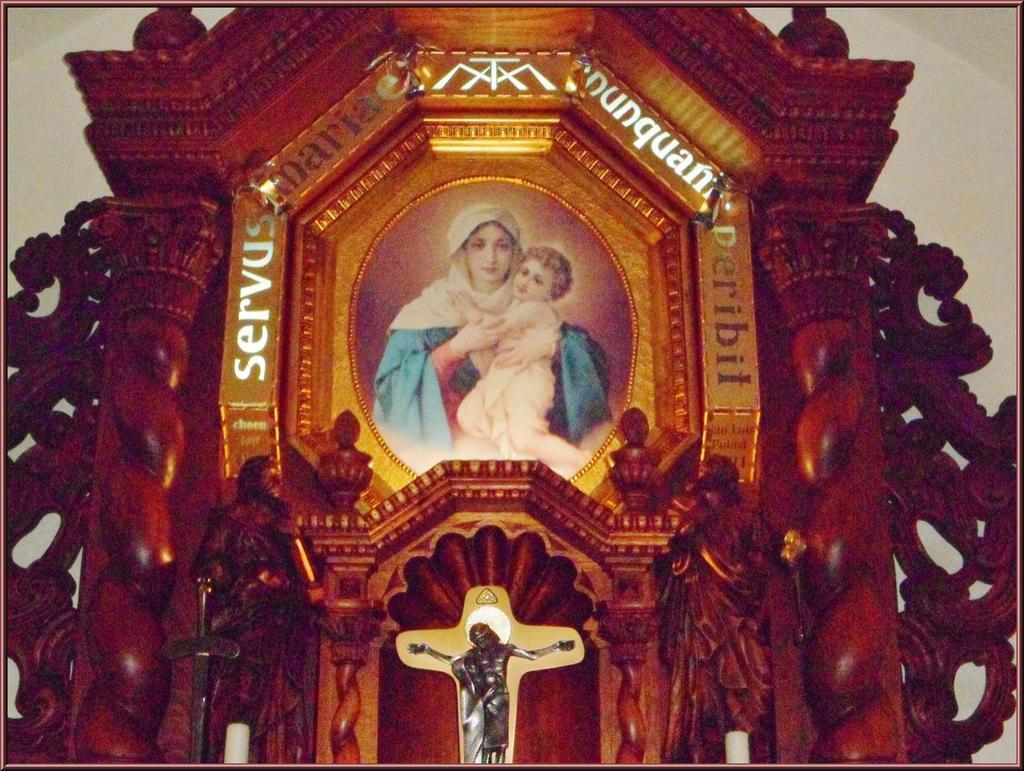What type of structure is present in the image? There is a wooden frame in the image. Where is the wooden frame located? The wooden frame is attached to a plain wall. What can be observed about the edges of the image? The image has borders. What type of sound can be heard coming from the dog in the image? There is no dog present in the image, so it is not possible to determine what sound might be heard. 